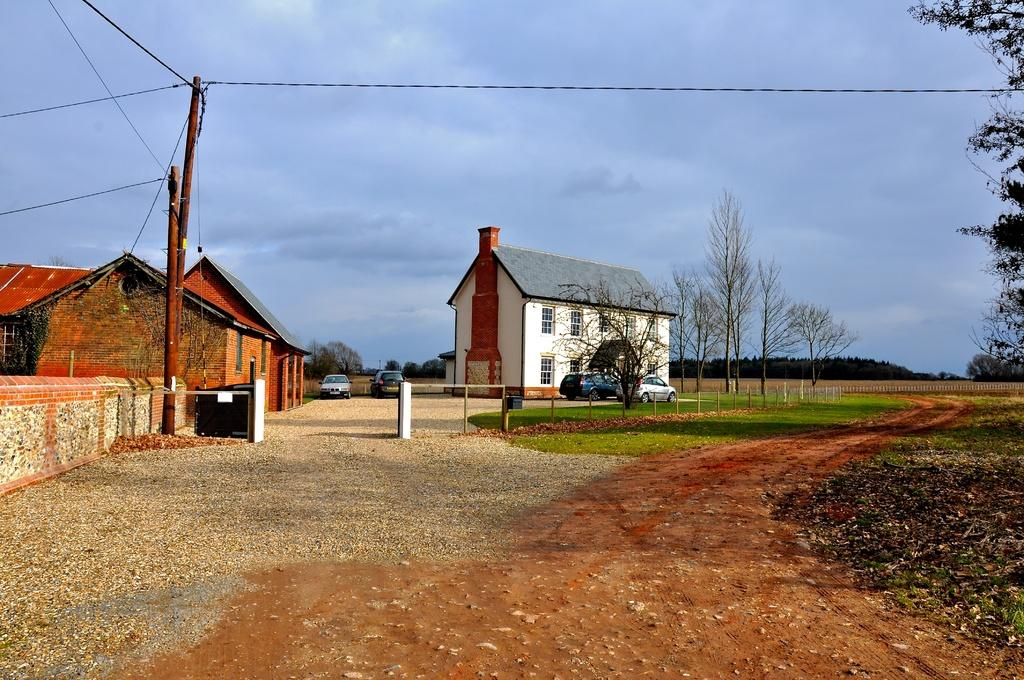What type of structures can be seen in the image? There are buildings in the image. What mode of transportation is present in the image? Motor vehicles are present in the image. What type of barrier is visible in the image? There is a fence in the image. What type of infrastructure is present in the image? Electric poles and electric cables are visible in the image. What type of natural elements can be seen in the image? Trees are in the image. What part of the sky is visible in the image? The sky is visible in the image, and clouds are present in the sky. What type of debris is visible on the ground? Shredded leaves are visible in the image. What type of man-made barriers are present in the image? Walls are present in the image. What type of path is visible in the image? A walking path is in the image. How many cherries are hanging from the electric poles in the image? There are no cherries present in the image, as it features buildings, motor vehicles, a fence, electric poles, electric cables, trees, the sky, clouds, shredded leaves, walls, and a walking path. What is the temperature in the image, and how does it affect the love between the people in the scene? The image does not provide information about the temperature or the emotions of the people, as it focuses on the physical elements and structures present in the scene. 